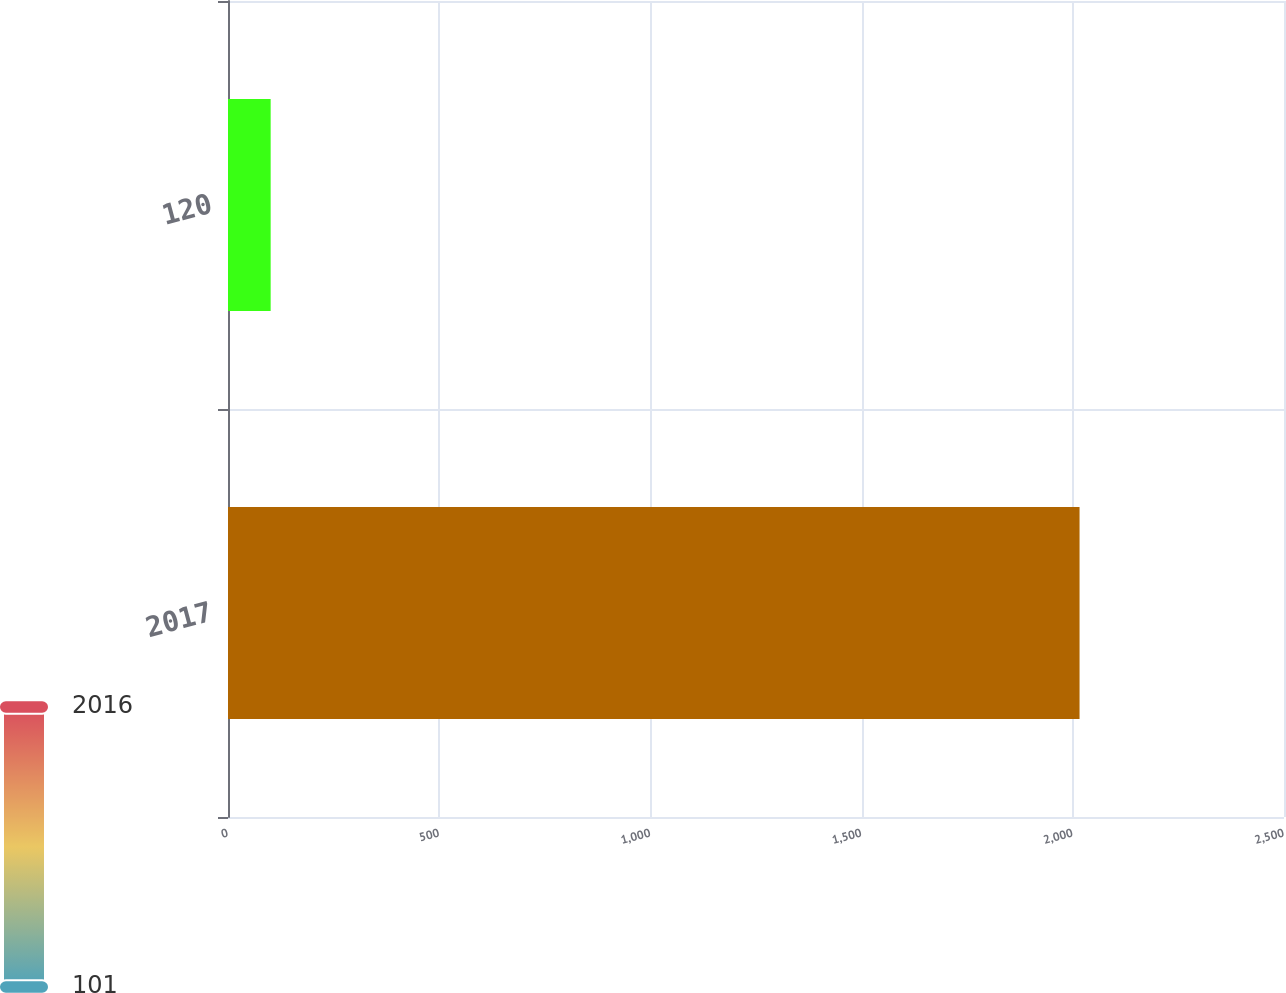<chart> <loc_0><loc_0><loc_500><loc_500><bar_chart><fcel>2017<fcel>120<nl><fcel>2016<fcel>101<nl></chart> 